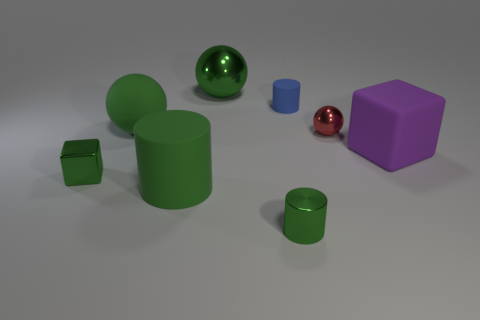What material is the tiny thing that is the same shape as the big purple rubber object?
Provide a short and direct response. Metal. Is the color of the large matte thing on the right side of the tiny green cylinder the same as the metal ball that is left of the red shiny sphere?
Your answer should be very brief. No. Is there a blue matte thing of the same size as the red sphere?
Ensure brevity in your answer.  Yes. What is the cylinder that is both behind the shiny cylinder and in front of the small green block made of?
Your answer should be very brief. Rubber. How many rubber objects are cylinders or big green balls?
Offer a very short reply. 3. What shape is the purple object that is made of the same material as the small blue thing?
Offer a very short reply. Cube. What number of small objects are both behind the rubber sphere and on the left side of the small metal cylinder?
Provide a short and direct response. 0. Is there anything else that has the same shape as the big purple rubber thing?
Your answer should be compact. Yes. How big is the metal ball that is in front of the tiny matte thing?
Offer a terse response. Small. How many other objects are there of the same color as the large matte cylinder?
Your response must be concise. 4. 